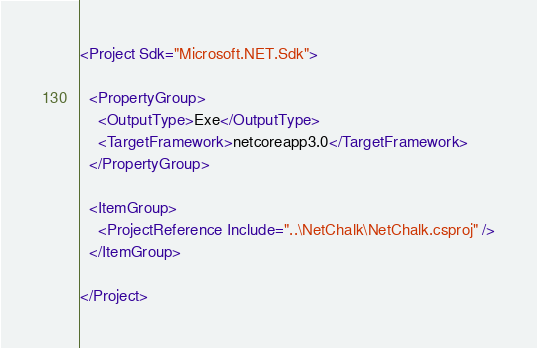Convert code to text. <code><loc_0><loc_0><loc_500><loc_500><_XML_><Project Sdk="Microsoft.NET.Sdk">

  <PropertyGroup>
    <OutputType>Exe</OutputType>
    <TargetFramework>netcoreapp3.0</TargetFramework>
  </PropertyGroup>

  <ItemGroup>
    <ProjectReference Include="..\NetChalk\NetChalk.csproj" />
  </ItemGroup>

</Project>
</code> 